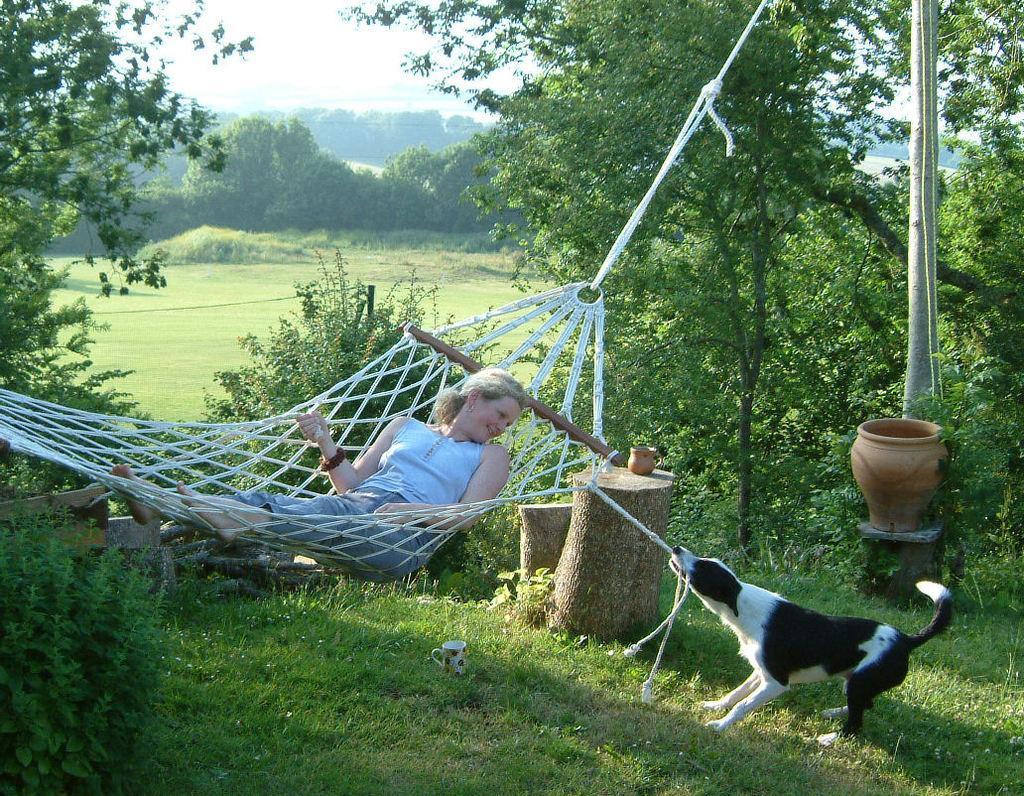How would you summarize this image in a sentence or two? In this picture I can see a woman lying on a hammock, on the right side a dog is pulling the rope and there is a pot. In the background there are trees, at the top there is the sky. 